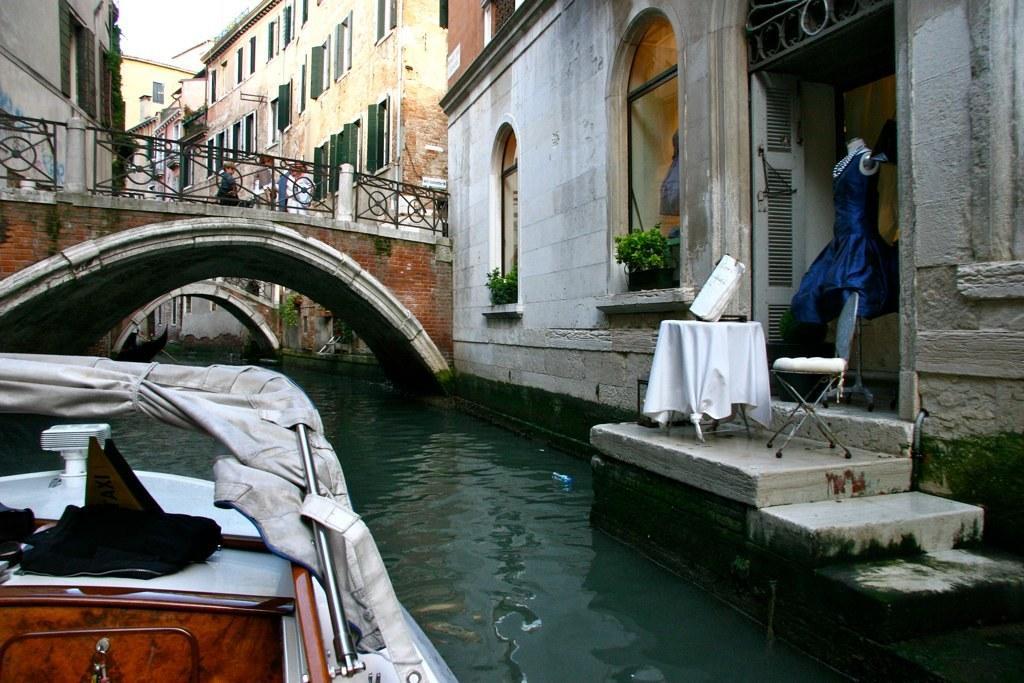In one or two sentences, can you explain what this image depicts? In this image there is a boat on a canal, on the right side there are buildings and there is a bridge across the canal. 